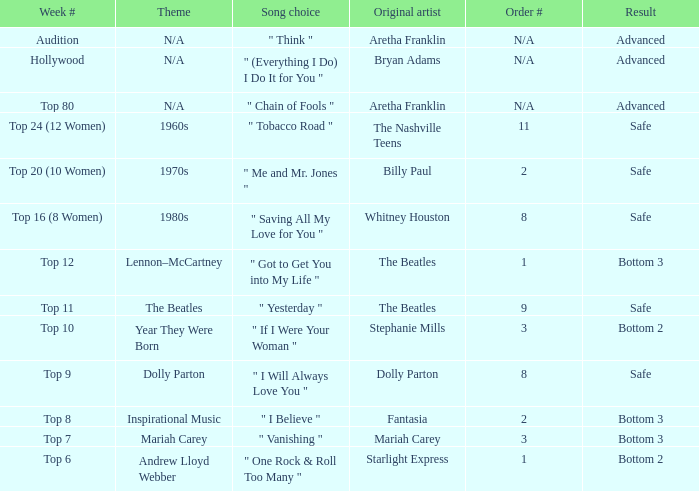Name the order number for the beatles and result is safe 9.0. 